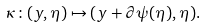<formula> <loc_0><loc_0><loc_500><loc_500>\kappa \colon ( y , \eta ) \mapsto ( y + \partial \psi ( \eta ) , \eta ) .</formula> 